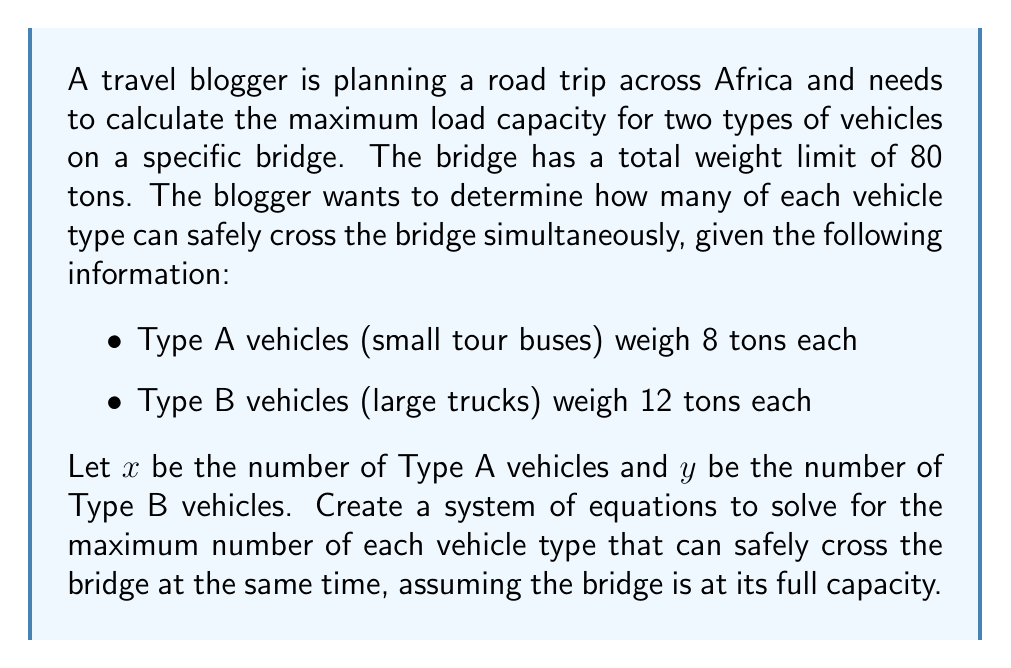Solve this math problem. Step 1: Set up the system of equations
We need two equations: one for the total weight limit and one to maximize the number of vehicles.

Equation 1 (Weight limit):
$$ 8x + 12y = 80 $$

Equation 2 (Maximizing vehicles):
We want to maximize the total number of vehicles, which is represented by $x + y$.

Step 2: Solve the system of equations
Rearrange Equation 1:
$$ y = \frac{80 - 8x}{12} = \frac{20 - 2x}{3} $$

Substitute this into the expression we want to maximize:
$$ x + y = x + \frac{20 - 2x}{3} $$

Step 3: Find the maximum value
To find the maximum, we need to find where the derivative of this expression equals zero:

$$ \frac{d}{dx}(x + \frac{20 - 2x}{3}) = 1 - \frac{2}{3} = \frac{1}{3} $$

Since this derivative is always positive, the maximum occurs at the highest possible integer value for x.

Step 4: Determine the highest possible integer values
Try x = 10:
$$ y = \frac{20 - 2(10)}{3} = 0 $$

This works, so the maximum is 10 Type A vehicles and 0 Type B vehicles.

Step 5: Verify the solution
$$ 8(10) + 12(0) = 80 $$

This satisfies the weight limit equation.
Answer: 10 Type A vehicles, 0 Type B vehicles 